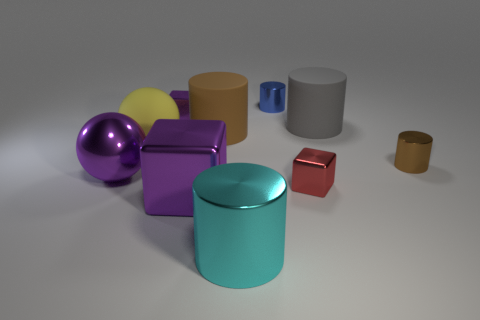There is a purple metallic block that is in front of the small red shiny thing; how big is it?
Your answer should be very brief. Large. What number of objects are either purple blocks or metallic objects that are in front of the metallic ball?
Make the answer very short. 4. What number of other objects are the same size as the purple shiny sphere?
Your answer should be compact. 5. There is another thing that is the same shape as the large yellow matte thing; what is it made of?
Keep it short and to the point. Metal. Is the number of large balls that are in front of the tiny blue cylinder greater than the number of large brown rubber objects?
Give a very brief answer. Yes. Is there any other thing that is the same color as the big metallic cylinder?
Your answer should be very brief. No. What shape is the large brown thing that is made of the same material as the gray object?
Give a very brief answer. Cylinder. Do the cylinder that is in front of the big metal sphere and the tiny purple block have the same material?
Your response must be concise. Yes. The tiny object that is the same color as the big cube is what shape?
Ensure brevity in your answer.  Cube. Do the tiny metal object to the right of the gray cylinder and the big rubber object to the right of the tiny red cube have the same color?
Offer a terse response. No. 